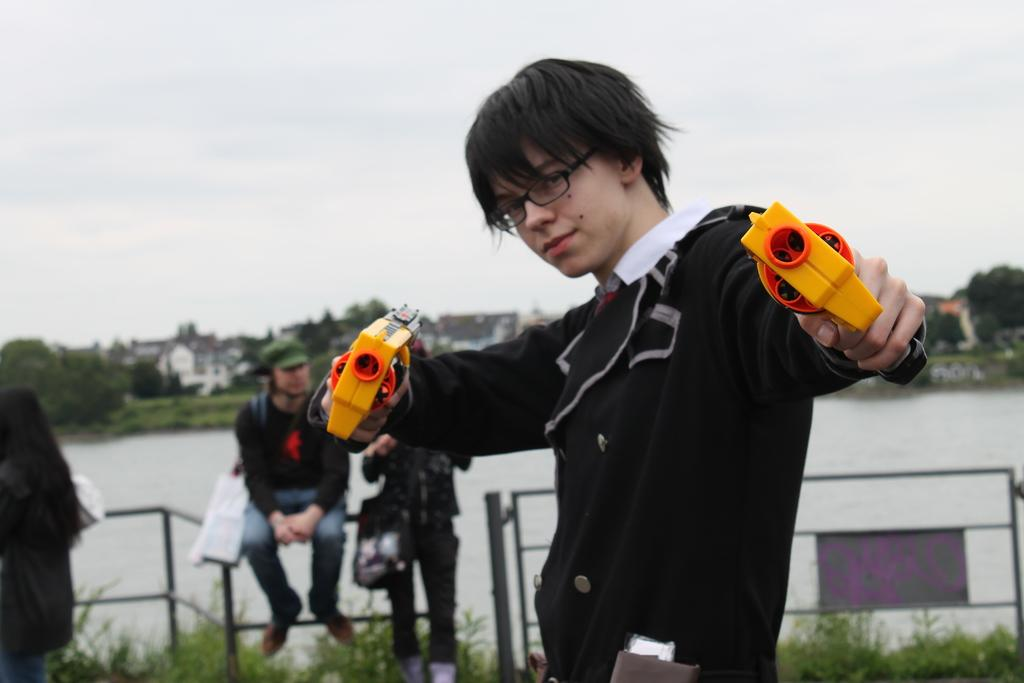What can be seen in the image? There is a person in the image. Can you describe the person's appearance? The person is wearing glasses. What is the person holding in the image? The person is holding guns. What is the person doing in the image? The person is watching. What can be seen in the background of the image? There are people, railing, plants, water, trees, houses, and the sky visible in the background of the image. How many people are visible in the background of the image? There are people in the background of the image. What type of vegetation is present in the background of the image? There are plants and trees in the background of the image. What type of structures can be seen in the background of the image? There are houses in the background of the image. What is the weather like in the image? The sky is visible in the background of the image, but the weather cannot be determined from the image alone. What type of organization is the person a part of in the image? There is no information about the person's organization in the image. What is the texture of the jar in the image? There is no jar present in the image. 